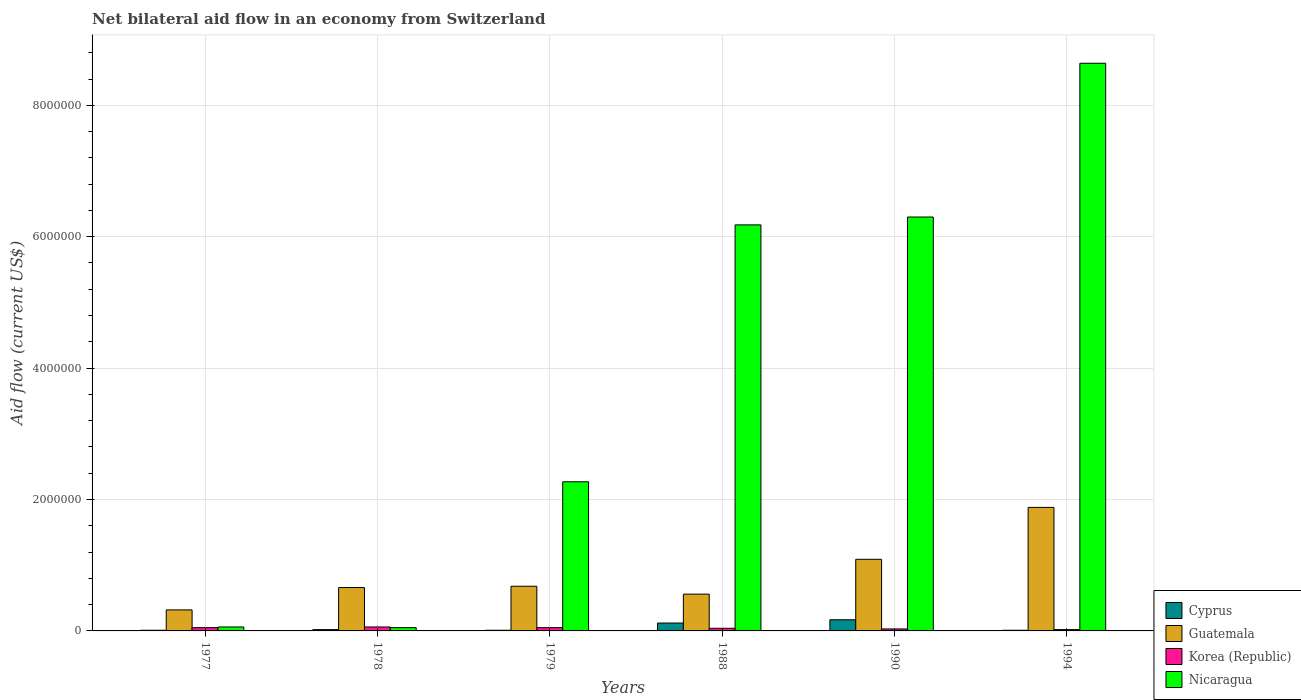How many different coloured bars are there?
Keep it short and to the point. 4. How many bars are there on the 3rd tick from the right?
Your answer should be very brief. 4. What is the label of the 6th group of bars from the left?
Offer a terse response. 1994. In how many cases, is the number of bars for a given year not equal to the number of legend labels?
Make the answer very short. 0. What is the net bilateral aid flow in Nicaragua in 1979?
Your answer should be compact. 2.27e+06. Across all years, what is the maximum net bilateral aid flow in Guatemala?
Give a very brief answer. 1.88e+06. What is the total net bilateral aid flow in Cyprus in the graph?
Offer a very short reply. 3.40e+05. What is the difference between the net bilateral aid flow in Korea (Republic) in 1994 and the net bilateral aid flow in Cyprus in 1990?
Give a very brief answer. -1.50e+05. What is the average net bilateral aid flow in Guatemala per year?
Offer a terse response. 8.65e+05. In how many years, is the net bilateral aid flow in Nicaragua greater than 3200000 US$?
Offer a very short reply. 3. What is the ratio of the net bilateral aid flow in Nicaragua in 1978 to that in 1988?
Provide a succinct answer. 0.01. Is the difference between the net bilateral aid flow in Cyprus in 1977 and 1978 greater than the difference between the net bilateral aid flow in Nicaragua in 1977 and 1978?
Make the answer very short. No. What is the difference between the highest and the second highest net bilateral aid flow in Nicaragua?
Make the answer very short. 2.34e+06. What is the difference between the highest and the lowest net bilateral aid flow in Guatemala?
Provide a succinct answer. 1.56e+06. In how many years, is the net bilateral aid flow in Nicaragua greater than the average net bilateral aid flow in Nicaragua taken over all years?
Your response must be concise. 3. Is it the case that in every year, the sum of the net bilateral aid flow in Cyprus and net bilateral aid flow in Korea (Republic) is greater than the sum of net bilateral aid flow in Guatemala and net bilateral aid flow in Nicaragua?
Provide a succinct answer. No. What does the 2nd bar from the left in 1978 represents?
Your answer should be compact. Guatemala. What does the 1st bar from the right in 1988 represents?
Keep it short and to the point. Nicaragua. Are the values on the major ticks of Y-axis written in scientific E-notation?
Your answer should be very brief. No. Does the graph contain any zero values?
Make the answer very short. No. Where does the legend appear in the graph?
Give a very brief answer. Bottom right. How many legend labels are there?
Ensure brevity in your answer.  4. How are the legend labels stacked?
Make the answer very short. Vertical. What is the title of the graph?
Your response must be concise. Net bilateral aid flow in an economy from Switzerland. Does "Malaysia" appear as one of the legend labels in the graph?
Your response must be concise. No. What is the label or title of the Y-axis?
Your response must be concise. Aid flow (current US$). What is the Aid flow (current US$) of Guatemala in 1977?
Your response must be concise. 3.20e+05. What is the Aid flow (current US$) of Korea (Republic) in 1977?
Make the answer very short. 5.00e+04. What is the Aid flow (current US$) of Nicaragua in 1977?
Your response must be concise. 6.00e+04. What is the Aid flow (current US$) of Cyprus in 1978?
Provide a short and direct response. 2.00e+04. What is the Aid flow (current US$) in Korea (Republic) in 1978?
Your answer should be very brief. 6.00e+04. What is the Aid flow (current US$) of Nicaragua in 1978?
Offer a terse response. 5.00e+04. What is the Aid flow (current US$) of Cyprus in 1979?
Make the answer very short. 10000. What is the Aid flow (current US$) in Guatemala in 1979?
Ensure brevity in your answer.  6.80e+05. What is the Aid flow (current US$) in Korea (Republic) in 1979?
Give a very brief answer. 5.00e+04. What is the Aid flow (current US$) of Nicaragua in 1979?
Give a very brief answer. 2.27e+06. What is the Aid flow (current US$) of Cyprus in 1988?
Make the answer very short. 1.20e+05. What is the Aid flow (current US$) of Guatemala in 1988?
Make the answer very short. 5.60e+05. What is the Aid flow (current US$) in Korea (Republic) in 1988?
Offer a terse response. 4.00e+04. What is the Aid flow (current US$) of Nicaragua in 1988?
Offer a terse response. 6.18e+06. What is the Aid flow (current US$) of Guatemala in 1990?
Give a very brief answer. 1.09e+06. What is the Aid flow (current US$) of Korea (Republic) in 1990?
Provide a succinct answer. 3.00e+04. What is the Aid flow (current US$) in Nicaragua in 1990?
Provide a succinct answer. 6.30e+06. What is the Aid flow (current US$) of Cyprus in 1994?
Make the answer very short. 10000. What is the Aid flow (current US$) of Guatemala in 1994?
Make the answer very short. 1.88e+06. What is the Aid flow (current US$) of Nicaragua in 1994?
Provide a short and direct response. 8.64e+06. Across all years, what is the maximum Aid flow (current US$) in Cyprus?
Ensure brevity in your answer.  1.70e+05. Across all years, what is the maximum Aid flow (current US$) in Guatemala?
Ensure brevity in your answer.  1.88e+06. Across all years, what is the maximum Aid flow (current US$) in Korea (Republic)?
Your answer should be very brief. 6.00e+04. Across all years, what is the maximum Aid flow (current US$) in Nicaragua?
Make the answer very short. 8.64e+06. Across all years, what is the minimum Aid flow (current US$) in Cyprus?
Your answer should be compact. 10000. Across all years, what is the minimum Aid flow (current US$) of Guatemala?
Offer a very short reply. 3.20e+05. Across all years, what is the minimum Aid flow (current US$) of Korea (Republic)?
Keep it short and to the point. 2.00e+04. Across all years, what is the minimum Aid flow (current US$) in Nicaragua?
Make the answer very short. 5.00e+04. What is the total Aid flow (current US$) in Guatemala in the graph?
Give a very brief answer. 5.19e+06. What is the total Aid flow (current US$) of Korea (Republic) in the graph?
Make the answer very short. 2.50e+05. What is the total Aid flow (current US$) of Nicaragua in the graph?
Provide a short and direct response. 2.35e+07. What is the difference between the Aid flow (current US$) in Guatemala in 1977 and that in 1979?
Your answer should be compact. -3.60e+05. What is the difference between the Aid flow (current US$) in Nicaragua in 1977 and that in 1979?
Make the answer very short. -2.21e+06. What is the difference between the Aid flow (current US$) in Guatemala in 1977 and that in 1988?
Provide a short and direct response. -2.40e+05. What is the difference between the Aid flow (current US$) of Nicaragua in 1977 and that in 1988?
Give a very brief answer. -6.12e+06. What is the difference between the Aid flow (current US$) of Guatemala in 1977 and that in 1990?
Your answer should be very brief. -7.70e+05. What is the difference between the Aid flow (current US$) of Nicaragua in 1977 and that in 1990?
Provide a short and direct response. -6.24e+06. What is the difference between the Aid flow (current US$) in Cyprus in 1977 and that in 1994?
Give a very brief answer. 0. What is the difference between the Aid flow (current US$) in Guatemala in 1977 and that in 1994?
Provide a short and direct response. -1.56e+06. What is the difference between the Aid flow (current US$) of Nicaragua in 1977 and that in 1994?
Provide a succinct answer. -8.58e+06. What is the difference between the Aid flow (current US$) of Cyprus in 1978 and that in 1979?
Provide a succinct answer. 10000. What is the difference between the Aid flow (current US$) in Guatemala in 1978 and that in 1979?
Provide a succinct answer. -2.00e+04. What is the difference between the Aid flow (current US$) in Korea (Republic) in 1978 and that in 1979?
Ensure brevity in your answer.  10000. What is the difference between the Aid flow (current US$) of Nicaragua in 1978 and that in 1979?
Your answer should be compact. -2.22e+06. What is the difference between the Aid flow (current US$) of Guatemala in 1978 and that in 1988?
Your answer should be compact. 1.00e+05. What is the difference between the Aid flow (current US$) in Korea (Republic) in 1978 and that in 1988?
Your response must be concise. 2.00e+04. What is the difference between the Aid flow (current US$) of Nicaragua in 1978 and that in 1988?
Your response must be concise. -6.13e+06. What is the difference between the Aid flow (current US$) of Guatemala in 1978 and that in 1990?
Offer a very short reply. -4.30e+05. What is the difference between the Aid flow (current US$) of Nicaragua in 1978 and that in 1990?
Keep it short and to the point. -6.25e+06. What is the difference between the Aid flow (current US$) in Cyprus in 1978 and that in 1994?
Offer a terse response. 10000. What is the difference between the Aid flow (current US$) in Guatemala in 1978 and that in 1994?
Make the answer very short. -1.22e+06. What is the difference between the Aid flow (current US$) of Korea (Republic) in 1978 and that in 1994?
Offer a very short reply. 4.00e+04. What is the difference between the Aid flow (current US$) of Nicaragua in 1978 and that in 1994?
Make the answer very short. -8.59e+06. What is the difference between the Aid flow (current US$) of Guatemala in 1979 and that in 1988?
Provide a short and direct response. 1.20e+05. What is the difference between the Aid flow (current US$) of Korea (Republic) in 1979 and that in 1988?
Offer a terse response. 10000. What is the difference between the Aid flow (current US$) of Nicaragua in 1979 and that in 1988?
Offer a terse response. -3.91e+06. What is the difference between the Aid flow (current US$) in Guatemala in 1979 and that in 1990?
Your response must be concise. -4.10e+05. What is the difference between the Aid flow (current US$) of Nicaragua in 1979 and that in 1990?
Provide a short and direct response. -4.03e+06. What is the difference between the Aid flow (current US$) in Cyprus in 1979 and that in 1994?
Give a very brief answer. 0. What is the difference between the Aid flow (current US$) of Guatemala in 1979 and that in 1994?
Ensure brevity in your answer.  -1.20e+06. What is the difference between the Aid flow (current US$) in Korea (Republic) in 1979 and that in 1994?
Give a very brief answer. 3.00e+04. What is the difference between the Aid flow (current US$) in Nicaragua in 1979 and that in 1994?
Give a very brief answer. -6.37e+06. What is the difference between the Aid flow (current US$) of Cyprus in 1988 and that in 1990?
Keep it short and to the point. -5.00e+04. What is the difference between the Aid flow (current US$) of Guatemala in 1988 and that in 1990?
Ensure brevity in your answer.  -5.30e+05. What is the difference between the Aid flow (current US$) of Korea (Republic) in 1988 and that in 1990?
Keep it short and to the point. 10000. What is the difference between the Aid flow (current US$) in Guatemala in 1988 and that in 1994?
Give a very brief answer. -1.32e+06. What is the difference between the Aid flow (current US$) of Korea (Republic) in 1988 and that in 1994?
Make the answer very short. 2.00e+04. What is the difference between the Aid flow (current US$) of Nicaragua in 1988 and that in 1994?
Make the answer very short. -2.46e+06. What is the difference between the Aid flow (current US$) of Guatemala in 1990 and that in 1994?
Your response must be concise. -7.90e+05. What is the difference between the Aid flow (current US$) of Nicaragua in 1990 and that in 1994?
Give a very brief answer. -2.34e+06. What is the difference between the Aid flow (current US$) in Cyprus in 1977 and the Aid flow (current US$) in Guatemala in 1978?
Ensure brevity in your answer.  -6.50e+05. What is the difference between the Aid flow (current US$) of Cyprus in 1977 and the Aid flow (current US$) of Korea (Republic) in 1978?
Give a very brief answer. -5.00e+04. What is the difference between the Aid flow (current US$) of Korea (Republic) in 1977 and the Aid flow (current US$) of Nicaragua in 1978?
Your response must be concise. 0. What is the difference between the Aid flow (current US$) in Cyprus in 1977 and the Aid flow (current US$) in Guatemala in 1979?
Your response must be concise. -6.70e+05. What is the difference between the Aid flow (current US$) of Cyprus in 1977 and the Aid flow (current US$) of Korea (Republic) in 1979?
Provide a succinct answer. -4.00e+04. What is the difference between the Aid flow (current US$) of Cyprus in 1977 and the Aid flow (current US$) of Nicaragua in 1979?
Offer a very short reply. -2.26e+06. What is the difference between the Aid flow (current US$) in Guatemala in 1977 and the Aid flow (current US$) in Korea (Republic) in 1979?
Your answer should be compact. 2.70e+05. What is the difference between the Aid flow (current US$) of Guatemala in 1977 and the Aid flow (current US$) of Nicaragua in 1979?
Ensure brevity in your answer.  -1.95e+06. What is the difference between the Aid flow (current US$) of Korea (Republic) in 1977 and the Aid flow (current US$) of Nicaragua in 1979?
Your response must be concise. -2.22e+06. What is the difference between the Aid flow (current US$) of Cyprus in 1977 and the Aid flow (current US$) of Guatemala in 1988?
Your answer should be compact. -5.50e+05. What is the difference between the Aid flow (current US$) of Cyprus in 1977 and the Aid flow (current US$) of Nicaragua in 1988?
Your response must be concise. -6.17e+06. What is the difference between the Aid flow (current US$) in Guatemala in 1977 and the Aid flow (current US$) in Korea (Republic) in 1988?
Provide a short and direct response. 2.80e+05. What is the difference between the Aid flow (current US$) of Guatemala in 1977 and the Aid flow (current US$) of Nicaragua in 1988?
Make the answer very short. -5.86e+06. What is the difference between the Aid flow (current US$) of Korea (Republic) in 1977 and the Aid flow (current US$) of Nicaragua in 1988?
Offer a very short reply. -6.13e+06. What is the difference between the Aid flow (current US$) of Cyprus in 1977 and the Aid flow (current US$) of Guatemala in 1990?
Your answer should be very brief. -1.08e+06. What is the difference between the Aid flow (current US$) of Cyprus in 1977 and the Aid flow (current US$) of Korea (Republic) in 1990?
Make the answer very short. -2.00e+04. What is the difference between the Aid flow (current US$) in Cyprus in 1977 and the Aid flow (current US$) in Nicaragua in 1990?
Make the answer very short. -6.29e+06. What is the difference between the Aid flow (current US$) in Guatemala in 1977 and the Aid flow (current US$) in Nicaragua in 1990?
Ensure brevity in your answer.  -5.98e+06. What is the difference between the Aid flow (current US$) in Korea (Republic) in 1977 and the Aid flow (current US$) in Nicaragua in 1990?
Ensure brevity in your answer.  -6.25e+06. What is the difference between the Aid flow (current US$) in Cyprus in 1977 and the Aid flow (current US$) in Guatemala in 1994?
Provide a succinct answer. -1.87e+06. What is the difference between the Aid flow (current US$) of Cyprus in 1977 and the Aid flow (current US$) of Korea (Republic) in 1994?
Provide a succinct answer. -10000. What is the difference between the Aid flow (current US$) in Cyprus in 1977 and the Aid flow (current US$) in Nicaragua in 1994?
Give a very brief answer. -8.63e+06. What is the difference between the Aid flow (current US$) of Guatemala in 1977 and the Aid flow (current US$) of Korea (Republic) in 1994?
Your response must be concise. 3.00e+05. What is the difference between the Aid flow (current US$) in Guatemala in 1977 and the Aid flow (current US$) in Nicaragua in 1994?
Your answer should be very brief. -8.32e+06. What is the difference between the Aid flow (current US$) of Korea (Republic) in 1977 and the Aid flow (current US$) of Nicaragua in 1994?
Offer a terse response. -8.59e+06. What is the difference between the Aid flow (current US$) of Cyprus in 1978 and the Aid flow (current US$) of Guatemala in 1979?
Your response must be concise. -6.60e+05. What is the difference between the Aid flow (current US$) in Cyprus in 1978 and the Aid flow (current US$) in Nicaragua in 1979?
Provide a short and direct response. -2.25e+06. What is the difference between the Aid flow (current US$) of Guatemala in 1978 and the Aid flow (current US$) of Nicaragua in 1979?
Your answer should be very brief. -1.61e+06. What is the difference between the Aid flow (current US$) in Korea (Republic) in 1978 and the Aid flow (current US$) in Nicaragua in 1979?
Your answer should be compact. -2.21e+06. What is the difference between the Aid flow (current US$) in Cyprus in 1978 and the Aid flow (current US$) in Guatemala in 1988?
Offer a very short reply. -5.40e+05. What is the difference between the Aid flow (current US$) in Cyprus in 1978 and the Aid flow (current US$) in Nicaragua in 1988?
Your answer should be very brief. -6.16e+06. What is the difference between the Aid flow (current US$) of Guatemala in 1978 and the Aid flow (current US$) of Korea (Republic) in 1988?
Your answer should be compact. 6.20e+05. What is the difference between the Aid flow (current US$) of Guatemala in 1978 and the Aid flow (current US$) of Nicaragua in 1988?
Ensure brevity in your answer.  -5.52e+06. What is the difference between the Aid flow (current US$) in Korea (Republic) in 1978 and the Aid flow (current US$) in Nicaragua in 1988?
Keep it short and to the point. -6.12e+06. What is the difference between the Aid flow (current US$) of Cyprus in 1978 and the Aid flow (current US$) of Guatemala in 1990?
Your answer should be very brief. -1.07e+06. What is the difference between the Aid flow (current US$) of Cyprus in 1978 and the Aid flow (current US$) of Nicaragua in 1990?
Your answer should be compact. -6.28e+06. What is the difference between the Aid flow (current US$) in Guatemala in 1978 and the Aid flow (current US$) in Korea (Republic) in 1990?
Your answer should be compact. 6.30e+05. What is the difference between the Aid flow (current US$) of Guatemala in 1978 and the Aid flow (current US$) of Nicaragua in 1990?
Offer a very short reply. -5.64e+06. What is the difference between the Aid flow (current US$) in Korea (Republic) in 1978 and the Aid flow (current US$) in Nicaragua in 1990?
Offer a terse response. -6.24e+06. What is the difference between the Aid flow (current US$) in Cyprus in 1978 and the Aid flow (current US$) in Guatemala in 1994?
Your answer should be very brief. -1.86e+06. What is the difference between the Aid flow (current US$) in Cyprus in 1978 and the Aid flow (current US$) in Korea (Republic) in 1994?
Provide a short and direct response. 0. What is the difference between the Aid flow (current US$) of Cyprus in 1978 and the Aid flow (current US$) of Nicaragua in 1994?
Offer a terse response. -8.62e+06. What is the difference between the Aid flow (current US$) of Guatemala in 1978 and the Aid flow (current US$) of Korea (Republic) in 1994?
Ensure brevity in your answer.  6.40e+05. What is the difference between the Aid flow (current US$) of Guatemala in 1978 and the Aid flow (current US$) of Nicaragua in 1994?
Offer a terse response. -7.98e+06. What is the difference between the Aid flow (current US$) in Korea (Republic) in 1978 and the Aid flow (current US$) in Nicaragua in 1994?
Make the answer very short. -8.58e+06. What is the difference between the Aid flow (current US$) of Cyprus in 1979 and the Aid flow (current US$) of Guatemala in 1988?
Give a very brief answer. -5.50e+05. What is the difference between the Aid flow (current US$) in Cyprus in 1979 and the Aid flow (current US$) in Nicaragua in 1988?
Give a very brief answer. -6.17e+06. What is the difference between the Aid flow (current US$) of Guatemala in 1979 and the Aid flow (current US$) of Korea (Republic) in 1988?
Provide a succinct answer. 6.40e+05. What is the difference between the Aid flow (current US$) of Guatemala in 1979 and the Aid flow (current US$) of Nicaragua in 1988?
Your response must be concise. -5.50e+06. What is the difference between the Aid flow (current US$) in Korea (Republic) in 1979 and the Aid flow (current US$) in Nicaragua in 1988?
Offer a terse response. -6.13e+06. What is the difference between the Aid flow (current US$) of Cyprus in 1979 and the Aid flow (current US$) of Guatemala in 1990?
Offer a very short reply. -1.08e+06. What is the difference between the Aid flow (current US$) in Cyprus in 1979 and the Aid flow (current US$) in Nicaragua in 1990?
Give a very brief answer. -6.29e+06. What is the difference between the Aid flow (current US$) of Guatemala in 1979 and the Aid flow (current US$) of Korea (Republic) in 1990?
Offer a terse response. 6.50e+05. What is the difference between the Aid flow (current US$) of Guatemala in 1979 and the Aid flow (current US$) of Nicaragua in 1990?
Provide a succinct answer. -5.62e+06. What is the difference between the Aid flow (current US$) of Korea (Republic) in 1979 and the Aid flow (current US$) of Nicaragua in 1990?
Your answer should be very brief. -6.25e+06. What is the difference between the Aid flow (current US$) in Cyprus in 1979 and the Aid flow (current US$) in Guatemala in 1994?
Provide a succinct answer. -1.87e+06. What is the difference between the Aid flow (current US$) of Cyprus in 1979 and the Aid flow (current US$) of Korea (Republic) in 1994?
Provide a succinct answer. -10000. What is the difference between the Aid flow (current US$) in Cyprus in 1979 and the Aid flow (current US$) in Nicaragua in 1994?
Keep it short and to the point. -8.63e+06. What is the difference between the Aid flow (current US$) of Guatemala in 1979 and the Aid flow (current US$) of Korea (Republic) in 1994?
Your response must be concise. 6.60e+05. What is the difference between the Aid flow (current US$) in Guatemala in 1979 and the Aid flow (current US$) in Nicaragua in 1994?
Your answer should be very brief. -7.96e+06. What is the difference between the Aid flow (current US$) of Korea (Republic) in 1979 and the Aid flow (current US$) of Nicaragua in 1994?
Your response must be concise. -8.59e+06. What is the difference between the Aid flow (current US$) in Cyprus in 1988 and the Aid flow (current US$) in Guatemala in 1990?
Give a very brief answer. -9.70e+05. What is the difference between the Aid flow (current US$) in Cyprus in 1988 and the Aid flow (current US$) in Korea (Republic) in 1990?
Offer a very short reply. 9.00e+04. What is the difference between the Aid flow (current US$) of Cyprus in 1988 and the Aid flow (current US$) of Nicaragua in 1990?
Your answer should be compact. -6.18e+06. What is the difference between the Aid flow (current US$) of Guatemala in 1988 and the Aid flow (current US$) of Korea (Republic) in 1990?
Make the answer very short. 5.30e+05. What is the difference between the Aid flow (current US$) in Guatemala in 1988 and the Aid flow (current US$) in Nicaragua in 1990?
Keep it short and to the point. -5.74e+06. What is the difference between the Aid flow (current US$) in Korea (Republic) in 1988 and the Aid flow (current US$) in Nicaragua in 1990?
Ensure brevity in your answer.  -6.26e+06. What is the difference between the Aid flow (current US$) in Cyprus in 1988 and the Aid flow (current US$) in Guatemala in 1994?
Your answer should be compact. -1.76e+06. What is the difference between the Aid flow (current US$) in Cyprus in 1988 and the Aid flow (current US$) in Korea (Republic) in 1994?
Provide a short and direct response. 1.00e+05. What is the difference between the Aid flow (current US$) of Cyprus in 1988 and the Aid flow (current US$) of Nicaragua in 1994?
Provide a short and direct response. -8.52e+06. What is the difference between the Aid flow (current US$) of Guatemala in 1988 and the Aid flow (current US$) of Korea (Republic) in 1994?
Your answer should be very brief. 5.40e+05. What is the difference between the Aid flow (current US$) of Guatemala in 1988 and the Aid flow (current US$) of Nicaragua in 1994?
Your answer should be very brief. -8.08e+06. What is the difference between the Aid flow (current US$) in Korea (Republic) in 1988 and the Aid flow (current US$) in Nicaragua in 1994?
Make the answer very short. -8.60e+06. What is the difference between the Aid flow (current US$) in Cyprus in 1990 and the Aid flow (current US$) in Guatemala in 1994?
Offer a terse response. -1.71e+06. What is the difference between the Aid flow (current US$) in Cyprus in 1990 and the Aid flow (current US$) in Nicaragua in 1994?
Your answer should be compact. -8.47e+06. What is the difference between the Aid flow (current US$) of Guatemala in 1990 and the Aid flow (current US$) of Korea (Republic) in 1994?
Make the answer very short. 1.07e+06. What is the difference between the Aid flow (current US$) in Guatemala in 1990 and the Aid flow (current US$) in Nicaragua in 1994?
Your answer should be compact. -7.55e+06. What is the difference between the Aid flow (current US$) of Korea (Republic) in 1990 and the Aid flow (current US$) of Nicaragua in 1994?
Make the answer very short. -8.61e+06. What is the average Aid flow (current US$) of Cyprus per year?
Give a very brief answer. 5.67e+04. What is the average Aid flow (current US$) of Guatemala per year?
Your answer should be very brief. 8.65e+05. What is the average Aid flow (current US$) of Korea (Republic) per year?
Give a very brief answer. 4.17e+04. What is the average Aid flow (current US$) of Nicaragua per year?
Your response must be concise. 3.92e+06. In the year 1977, what is the difference between the Aid flow (current US$) in Cyprus and Aid flow (current US$) in Guatemala?
Your answer should be very brief. -3.10e+05. In the year 1977, what is the difference between the Aid flow (current US$) in Cyprus and Aid flow (current US$) in Korea (Republic)?
Your answer should be compact. -4.00e+04. In the year 1977, what is the difference between the Aid flow (current US$) of Cyprus and Aid flow (current US$) of Nicaragua?
Offer a terse response. -5.00e+04. In the year 1977, what is the difference between the Aid flow (current US$) of Guatemala and Aid flow (current US$) of Nicaragua?
Your answer should be compact. 2.60e+05. In the year 1977, what is the difference between the Aid flow (current US$) of Korea (Republic) and Aid flow (current US$) of Nicaragua?
Make the answer very short. -10000. In the year 1978, what is the difference between the Aid flow (current US$) of Cyprus and Aid flow (current US$) of Guatemala?
Provide a succinct answer. -6.40e+05. In the year 1978, what is the difference between the Aid flow (current US$) of Cyprus and Aid flow (current US$) of Nicaragua?
Provide a succinct answer. -3.00e+04. In the year 1978, what is the difference between the Aid flow (current US$) in Korea (Republic) and Aid flow (current US$) in Nicaragua?
Provide a short and direct response. 10000. In the year 1979, what is the difference between the Aid flow (current US$) of Cyprus and Aid flow (current US$) of Guatemala?
Give a very brief answer. -6.70e+05. In the year 1979, what is the difference between the Aid flow (current US$) of Cyprus and Aid flow (current US$) of Nicaragua?
Offer a terse response. -2.26e+06. In the year 1979, what is the difference between the Aid flow (current US$) in Guatemala and Aid flow (current US$) in Korea (Republic)?
Make the answer very short. 6.30e+05. In the year 1979, what is the difference between the Aid flow (current US$) of Guatemala and Aid flow (current US$) of Nicaragua?
Offer a very short reply. -1.59e+06. In the year 1979, what is the difference between the Aid flow (current US$) of Korea (Republic) and Aid flow (current US$) of Nicaragua?
Ensure brevity in your answer.  -2.22e+06. In the year 1988, what is the difference between the Aid flow (current US$) in Cyprus and Aid flow (current US$) in Guatemala?
Ensure brevity in your answer.  -4.40e+05. In the year 1988, what is the difference between the Aid flow (current US$) of Cyprus and Aid flow (current US$) of Nicaragua?
Ensure brevity in your answer.  -6.06e+06. In the year 1988, what is the difference between the Aid flow (current US$) in Guatemala and Aid flow (current US$) in Korea (Republic)?
Offer a very short reply. 5.20e+05. In the year 1988, what is the difference between the Aid flow (current US$) of Guatemala and Aid flow (current US$) of Nicaragua?
Keep it short and to the point. -5.62e+06. In the year 1988, what is the difference between the Aid flow (current US$) in Korea (Republic) and Aid flow (current US$) in Nicaragua?
Offer a terse response. -6.14e+06. In the year 1990, what is the difference between the Aid flow (current US$) of Cyprus and Aid flow (current US$) of Guatemala?
Your response must be concise. -9.20e+05. In the year 1990, what is the difference between the Aid flow (current US$) in Cyprus and Aid flow (current US$) in Nicaragua?
Your answer should be very brief. -6.13e+06. In the year 1990, what is the difference between the Aid flow (current US$) of Guatemala and Aid flow (current US$) of Korea (Republic)?
Make the answer very short. 1.06e+06. In the year 1990, what is the difference between the Aid flow (current US$) of Guatemala and Aid flow (current US$) of Nicaragua?
Give a very brief answer. -5.21e+06. In the year 1990, what is the difference between the Aid flow (current US$) of Korea (Republic) and Aid flow (current US$) of Nicaragua?
Make the answer very short. -6.27e+06. In the year 1994, what is the difference between the Aid flow (current US$) of Cyprus and Aid flow (current US$) of Guatemala?
Your answer should be compact. -1.87e+06. In the year 1994, what is the difference between the Aid flow (current US$) of Cyprus and Aid flow (current US$) of Korea (Republic)?
Your answer should be very brief. -10000. In the year 1994, what is the difference between the Aid flow (current US$) in Cyprus and Aid flow (current US$) in Nicaragua?
Offer a very short reply. -8.63e+06. In the year 1994, what is the difference between the Aid flow (current US$) in Guatemala and Aid flow (current US$) in Korea (Republic)?
Offer a terse response. 1.86e+06. In the year 1994, what is the difference between the Aid flow (current US$) of Guatemala and Aid flow (current US$) of Nicaragua?
Make the answer very short. -6.76e+06. In the year 1994, what is the difference between the Aid flow (current US$) in Korea (Republic) and Aid flow (current US$) in Nicaragua?
Make the answer very short. -8.62e+06. What is the ratio of the Aid flow (current US$) of Cyprus in 1977 to that in 1978?
Keep it short and to the point. 0.5. What is the ratio of the Aid flow (current US$) of Guatemala in 1977 to that in 1978?
Give a very brief answer. 0.48. What is the ratio of the Aid flow (current US$) in Korea (Republic) in 1977 to that in 1978?
Make the answer very short. 0.83. What is the ratio of the Aid flow (current US$) of Guatemala in 1977 to that in 1979?
Provide a short and direct response. 0.47. What is the ratio of the Aid flow (current US$) in Korea (Republic) in 1977 to that in 1979?
Your answer should be compact. 1. What is the ratio of the Aid flow (current US$) in Nicaragua in 1977 to that in 1979?
Offer a very short reply. 0.03. What is the ratio of the Aid flow (current US$) in Cyprus in 1977 to that in 1988?
Offer a very short reply. 0.08. What is the ratio of the Aid flow (current US$) in Guatemala in 1977 to that in 1988?
Ensure brevity in your answer.  0.57. What is the ratio of the Aid flow (current US$) in Korea (Republic) in 1977 to that in 1988?
Provide a succinct answer. 1.25. What is the ratio of the Aid flow (current US$) in Nicaragua in 1977 to that in 1988?
Provide a succinct answer. 0.01. What is the ratio of the Aid flow (current US$) in Cyprus in 1977 to that in 1990?
Your response must be concise. 0.06. What is the ratio of the Aid flow (current US$) of Guatemala in 1977 to that in 1990?
Offer a terse response. 0.29. What is the ratio of the Aid flow (current US$) in Nicaragua in 1977 to that in 1990?
Offer a terse response. 0.01. What is the ratio of the Aid flow (current US$) in Cyprus in 1977 to that in 1994?
Your answer should be compact. 1. What is the ratio of the Aid flow (current US$) in Guatemala in 1977 to that in 1994?
Make the answer very short. 0.17. What is the ratio of the Aid flow (current US$) in Korea (Republic) in 1977 to that in 1994?
Keep it short and to the point. 2.5. What is the ratio of the Aid flow (current US$) in Nicaragua in 1977 to that in 1994?
Ensure brevity in your answer.  0.01. What is the ratio of the Aid flow (current US$) of Guatemala in 1978 to that in 1979?
Your answer should be compact. 0.97. What is the ratio of the Aid flow (current US$) in Nicaragua in 1978 to that in 1979?
Give a very brief answer. 0.02. What is the ratio of the Aid flow (current US$) in Guatemala in 1978 to that in 1988?
Your answer should be compact. 1.18. What is the ratio of the Aid flow (current US$) in Korea (Republic) in 1978 to that in 1988?
Provide a short and direct response. 1.5. What is the ratio of the Aid flow (current US$) of Nicaragua in 1978 to that in 1988?
Keep it short and to the point. 0.01. What is the ratio of the Aid flow (current US$) of Cyprus in 1978 to that in 1990?
Offer a very short reply. 0.12. What is the ratio of the Aid flow (current US$) of Guatemala in 1978 to that in 1990?
Keep it short and to the point. 0.61. What is the ratio of the Aid flow (current US$) in Korea (Republic) in 1978 to that in 1990?
Provide a succinct answer. 2. What is the ratio of the Aid flow (current US$) in Nicaragua in 1978 to that in 1990?
Keep it short and to the point. 0.01. What is the ratio of the Aid flow (current US$) of Guatemala in 1978 to that in 1994?
Provide a succinct answer. 0.35. What is the ratio of the Aid flow (current US$) of Korea (Republic) in 1978 to that in 1994?
Your answer should be very brief. 3. What is the ratio of the Aid flow (current US$) in Nicaragua in 1978 to that in 1994?
Make the answer very short. 0.01. What is the ratio of the Aid flow (current US$) in Cyprus in 1979 to that in 1988?
Provide a succinct answer. 0.08. What is the ratio of the Aid flow (current US$) of Guatemala in 1979 to that in 1988?
Ensure brevity in your answer.  1.21. What is the ratio of the Aid flow (current US$) of Korea (Republic) in 1979 to that in 1988?
Your response must be concise. 1.25. What is the ratio of the Aid flow (current US$) of Nicaragua in 1979 to that in 1988?
Make the answer very short. 0.37. What is the ratio of the Aid flow (current US$) in Cyprus in 1979 to that in 1990?
Make the answer very short. 0.06. What is the ratio of the Aid flow (current US$) of Guatemala in 1979 to that in 1990?
Give a very brief answer. 0.62. What is the ratio of the Aid flow (current US$) in Nicaragua in 1979 to that in 1990?
Ensure brevity in your answer.  0.36. What is the ratio of the Aid flow (current US$) in Cyprus in 1979 to that in 1994?
Offer a terse response. 1. What is the ratio of the Aid flow (current US$) in Guatemala in 1979 to that in 1994?
Offer a very short reply. 0.36. What is the ratio of the Aid flow (current US$) of Korea (Republic) in 1979 to that in 1994?
Ensure brevity in your answer.  2.5. What is the ratio of the Aid flow (current US$) of Nicaragua in 1979 to that in 1994?
Provide a succinct answer. 0.26. What is the ratio of the Aid flow (current US$) in Cyprus in 1988 to that in 1990?
Make the answer very short. 0.71. What is the ratio of the Aid flow (current US$) in Guatemala in 1988 to that in 1990?
Your answer should be very brief. 0.51. What is the ratio of the Aid flow (current US$) of Korea (Republic) in 1988 to that in 1990?
Keep it short and to the point. 1.33. What is the ratio of the Aid flow (current US$) of Guatemala in 1988 to that in 1994?
Ensure brevity in your answer.  0.3. What is the ratio of the Aid flow (current US$) of Nicaragua in 1988 to that in 1994?
Give a very brief answer. 0.72. What is the ratio of the Aid flow (current US$) of Cyprus in 1990 to that in 1994?
Provide a succinct answer. 17. What is the ratio of the Aid flow (current US$) in Guatemala in 1990 to that in 1994?
Your answer should be very brief. 0.58. What is the ratio of the Aid flow (current US$) in Korea (Republic) in 1990 to that in 1994?
Your response must be concise. 1.5. What is the ratio of the Aid flow (current US$) in Nicaragua in 1990 to that in 1994?
Your response must be concise. 0.73. What is the difference between the highest and the second highest Aid flow (current US$) of Cyprus?
Ensure brevity in your answer.  5.00e+04. What is the difference between the highest and the second highest Aid flow (current US$) of Guatemala?
Give a very brief answer. 7.90e+05. What is the difference between the highest and the second highest Aid flow (current US$) in Korea (Republic)?
Your answer should be compact. 10000. What is the difference between the highest and the second highest Aid flow (current US$) in Nicaragua?
Ensure brevity in your answer.  2.34e+06. What is the difference between the highest and the lowest Aid flow (current US$) of Cyprus?
Provide a succinct answer. 1.60e+05. What is the difference between the highest and the lowest Aid flow (current US$) in Guatemala?
Offer a terse response. 1.56e+06. What is the difference between the highest and the lowest Aid flow (current US$) in Korea (Republic)?
Make the answer very short. 4.00e+04. What is the difference between the highest and the lowest Aid flow (current US$) in Nicaragua?
Provide a short and direct response. 8.59e+06. 